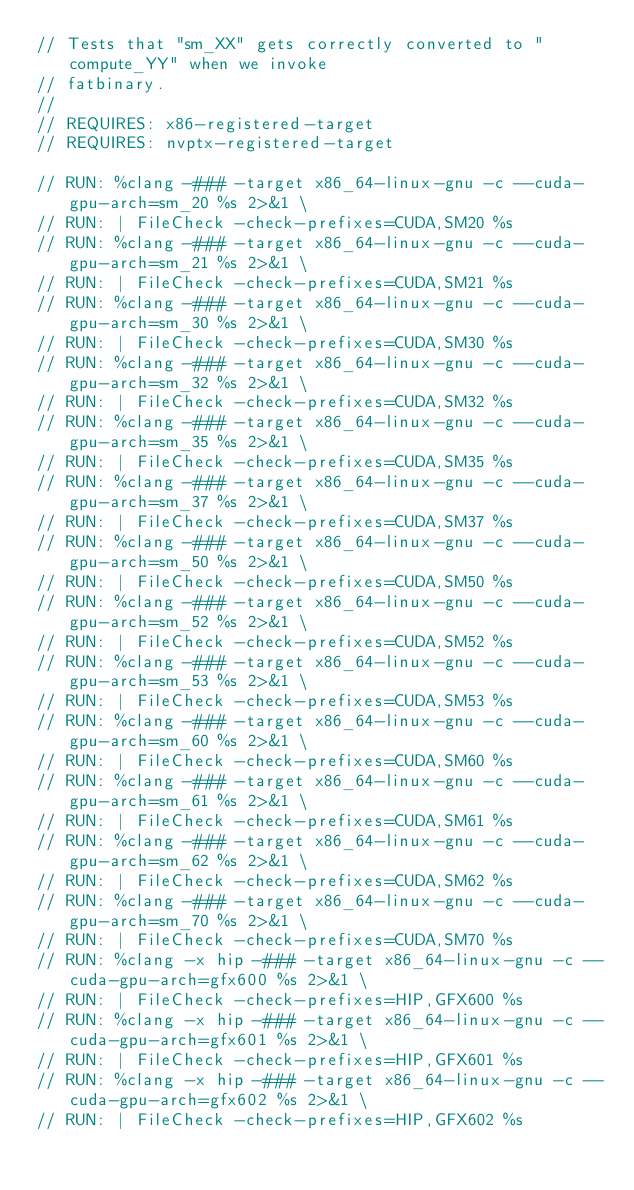Convert code to text. <code><loc_0><loc_0><loc_500><loc_500><_Cuda_>// Tests that "sm_XX" gets correctly converted to "compute_YY" when we invoke
// fatbinary.
//
// REQUIRES: x86-registered-target
// REQUIRES: nvptx-registered-target

// RUN: %clang -### -target x86_64-linux-gnu -c --cuda-gpu-arch=sm_20 %s 2>&1 \
// RUN: | FileCheck -check-prefixes=CUDA,SM20 %s
// RUN: %clang -### -target x86_64-linux-gnu -c --cuda-gpu-arch=sm_21 %s 2>&1 \
// RUN: | FileCheck -check-prefixes=CUDA,SM21 %s
// RUN: %clang -### -target x86_64-linux-gnu -c --cuda-gpu-arch=sm_30 %s 2>&1 \
// RUN: | FileCheck -check-prefixes=CUDA,SM30 %s
// RUN: %clang -### -target x86_64-linux-gnu -c --cuda-gpu-arch=sm_32 %s 2>&1 \
// RUN: | FileCheck -check-prefixes=CUDA,SM32 %s
// RUN: %clang -### -target x86_64-linux-gnu -c --cuda-gpu-arch=sm_35 %s 2>&1 \
// RUN: | FileCheck -check-prefixes=CUDA,SM35 %s
// RUN: %clang -### -target x86_64-linux-gnu -c --cuda-gpu-arch=sm_37 %s 2>&1 \
// RUN: | FileCheck -check-prefixes=CUDA,SM37 %s
// RUN: %clang -### -target x86_64-linux-gnu -c --cuda-gpu-arch=sm_50 %s 2>&1 \
// RUN: | FileCheck -check-prefixes=CUDA,SM50 %s
// RUN: %clang -### -target x86_64-linux-gnu -c --cuda-gpu-arch=sm_52 %s 2>&1 \
// RUN: | FileCheck -check-prefixes=CUDA,SM52 %s
// RUN: %clang -### -target x86_64-linux-gnu -c --cuda-gpu-arch=sm_53 %s 2>&1 \
// RUN: | FileCheck -check-prefixes=CUDA,SM53 %s
// RUN: %clang -### -target x86_64-linux-gnu -c --cuda-gpu-arch=sm_60 %s 2>&1 \
// RUN: | FileCheck -check-prefixes=CUDA,SM60 %s
// RUN: %clang -### -target x86_64-linux-gnu -c --cuda-gpu-arch=sm_61 %s 2>&1 \
// RUN: | FileCheck -check-prefixes=CUDA,SM61 %s
// RUN: %clang -### -target x86_64-linux-gnu -c --cuda-gpu-arch=sm_62 %s 2>&1 \
// RUN: | FileCheck -check-prefixes=CUDA,SM62 %s
// RUN: %clang -### -target x86_64-linux-gnu -c --cuda-gpu-arch=sm_70 %s 2>&1 \
// RUN: | FileCheck -check-prefixes=CUDA,SM70 %s
// RUN: %clang -x hip -### -target x86_64-linux-gnu -c --cuda-gpu-arch=gfx600 %s 2>&1 \
// RUN: | FileCheck -check-prefixes=HIP,GFX600 %s
// RUN: %clang -x hip -### -target x86_64-linux-gnu -c --cuda-gpu-arch=gfx601 %s 2>&1 \
// RUN: | FileCheck -check-prefixes=HIP,GFX601 %s
// RUN: %clang -x hip -### -target x86_64-linux-gnu -c --cuda-gpu-arch=gfx602 %s 2>&1 \
// RUN: | FileCheck -check-prefixes=HIP,GFX602 %s</code> 